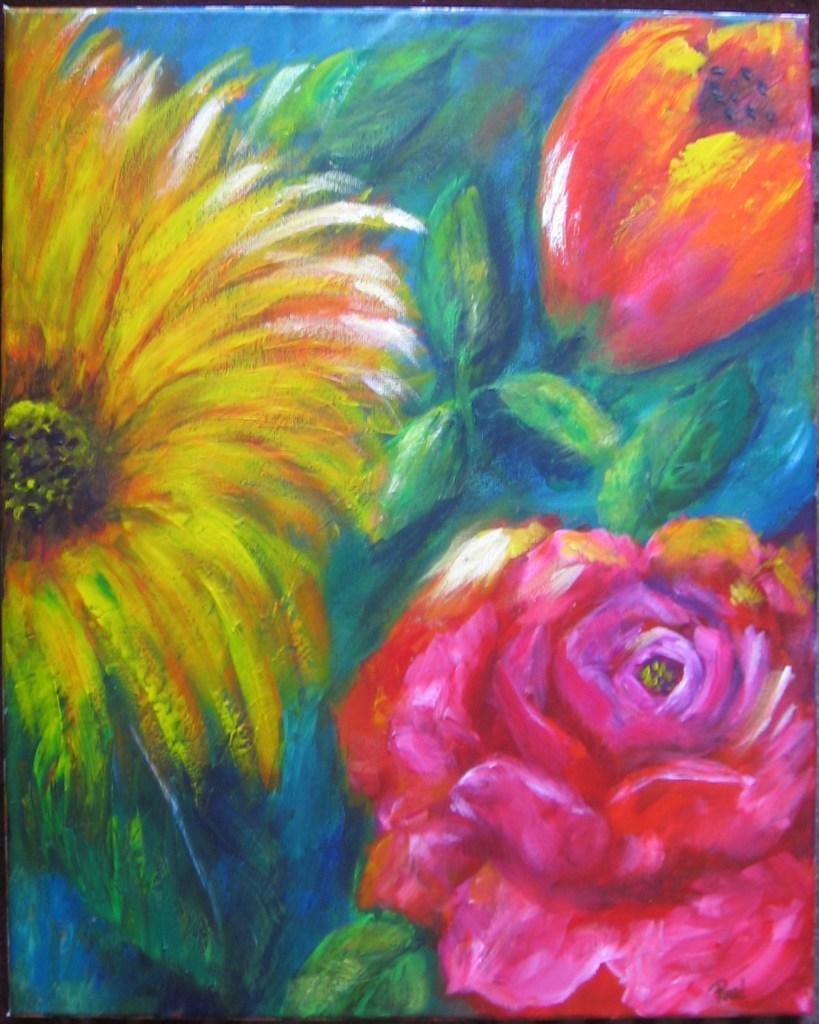Describe this image in one or two sentences. In this picture there is a painting of flowers and leaves. 